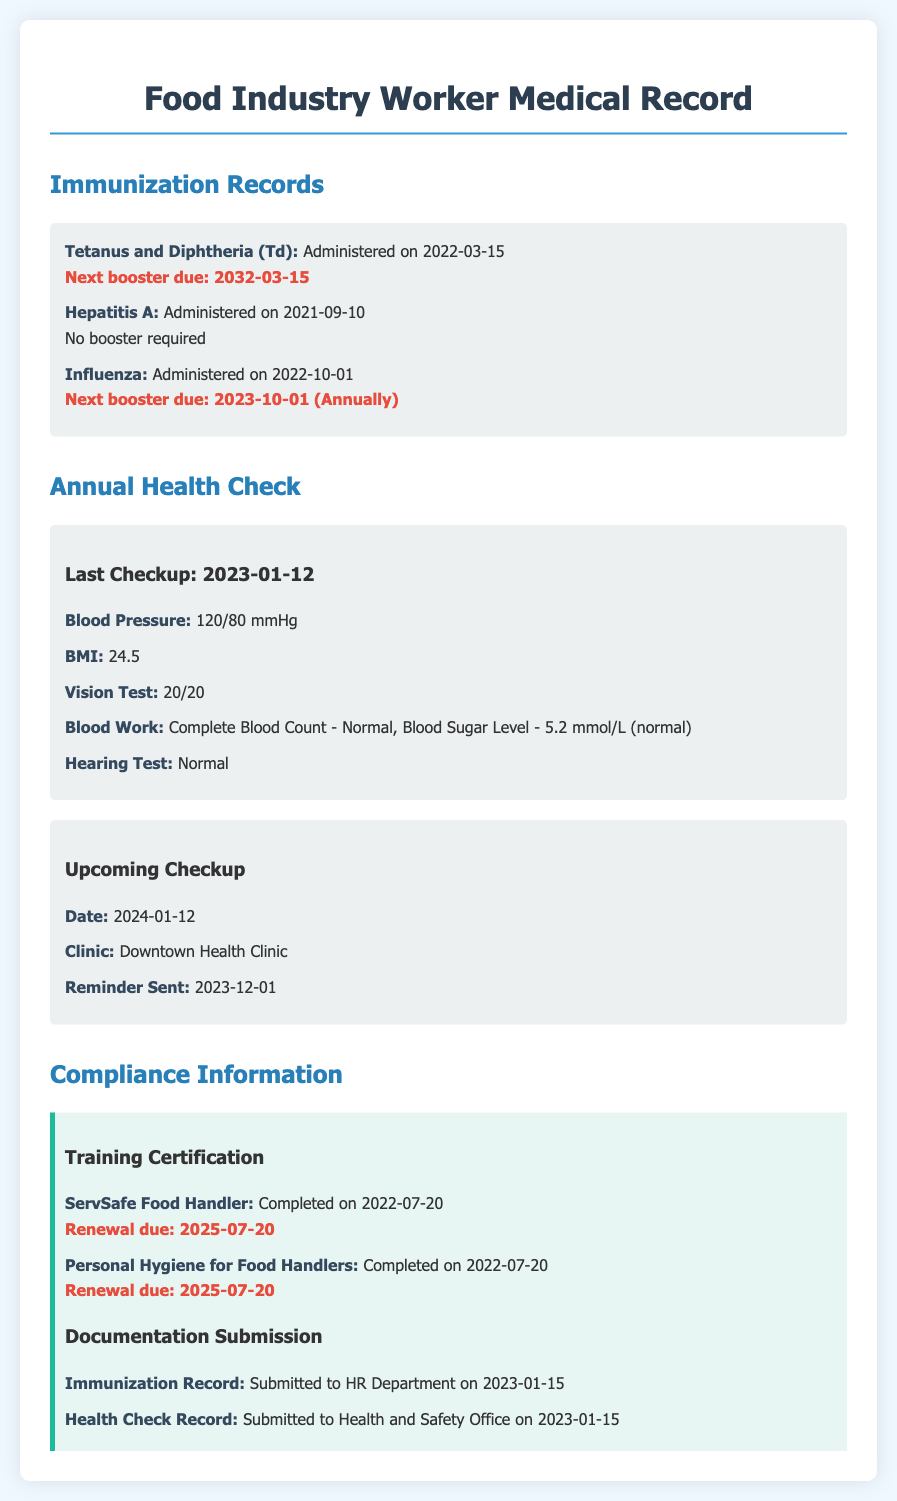What date was the last annual health check? The document specifies the date of the last annual health check as 2023-01-12.
Answer: 2023-01-12 When is the next booster for Tetanus and Diphtheria? According to the immunization records, the next booster for Tetanus and Diphtheria is due on 2032-03-15.
Answer: 2032-03-15 What is the BMI recorded during the last health check? The BMI recorded during the last health check is mentioned as 24.5 in the document.
Answer: 24.5 What type of vaccine was administered on 2021-09-10? The document indicates that the vaccine administered on 2021-09-10 is Hepatitis A.
Answer: Hepatitis A When was the last reminder sent for the upcoming checkup? The document states that the last reminder for the upcoming checkup was sent on 2023-12-01.
Answer: 2023-12-01 What is the name of the clinic for the upcoming health check? The upcoming health check will take place at Downtown Health Clinic, as per the document.
Answer: Downtown Health Clinic What was the result of the hearing test? The document shows that the result of the hearing test is classified as normal.
Answer: Normal When was the ServSafe Food Handler training completed? The completion date for the ServSafe Food Handler training is provided as 2022-07-20.
Answer: 2022-07-20 What is due for renewal on 2025-07-20? The document indicates that both the ServSafe Food Handler training and Personal Hygiene for Food Handlers training are due for renewal on this date.
Answer: 2025-07-20 